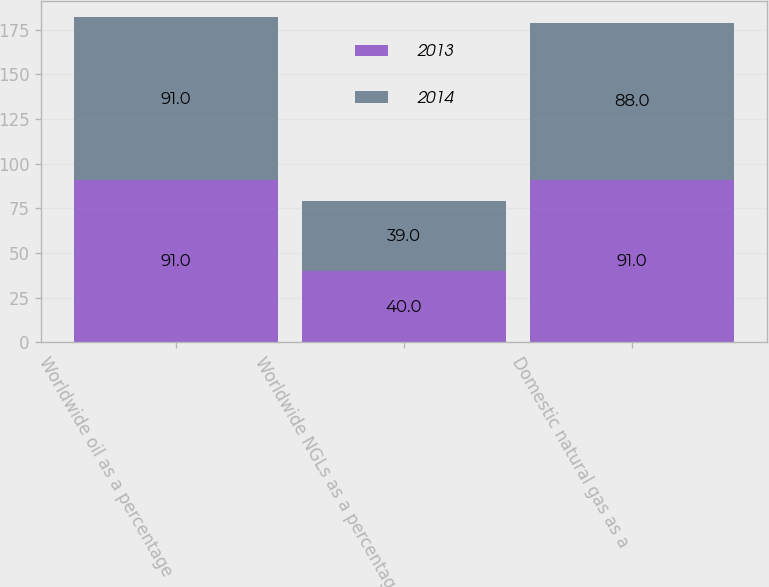Convert chart. <chart><loc_0><loc_0><loc_500><loc_500><stacked_bar_chart><ecel><fcel>Worldwide oil as a percentage<fcel>Worldwide NGLs as a percentage<fcel>Domestic natural gas as a<nl><fcel>2013<fcel>91<fcel>40<fcel>91<nl><fcel>2014<fcel>91<fcel>39<fcel>88<nl></chart> 